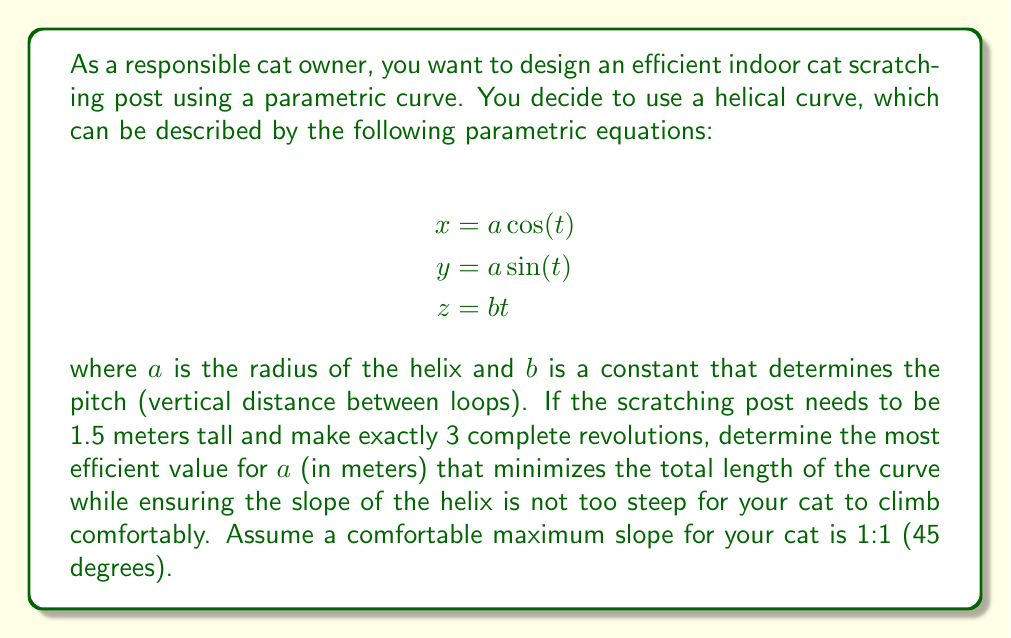Solve this math problem. Let's approach this problem step by step:

1) First, we need to understand the relationship between $a$, $b$, and the height of the post:
   - Height = $1.5$ m
   - Number of revolutions = 3
   - Total angle traversed = $3 \cdot 2\pi = 6\pi$
   
   We can write: $1.5 = b \cdot 6\pi$
   Therefore, $b = \frac{1.5}{6\pi} = \frac{1}{4\pi} \approx 0.0796$ m

2) The slope of the helix is given by $\frac{b}{a}$. For a maximum slope of 1:1, we need:

   $\frac{b}{a} \leq 1$
   $\frac{1}{4\pi a} \leq 1$
   $a \geq \frac{1}{4\pi} \approx 0.0796$ m

3) Now, we need to find the length of the helix. The arc length of a parametric curve is given by:

   $$L = \int_{0}^{6\pi} \sqrt{\left(\frac{dx}{dt}\right)^2 + \left(\frac{dy}{dt}\right)^2 + \left(\frac{dz}{dt}\right)^2} dt$$

4) Calculating the derivatives:
   $\frac{dx}{dt} = -a \sin(t)$
   $\frac{dy}{dt} = a \cos(t)$
   $\frac{dz}{dt} = b = \frac{1}{4\pi}$

5) Substituting into the arc length formula:

   $$L = \int_{0}^{6\pi} \sqrt{(-a \sin(t))^2 + (a \cos(t))^2 + (\frac{1}{4\pi})^2} dt$$
   $$= \int_{0}^{6\pi} \sqrt{a^2 (\sin^2(t) + \cos^2(t)) + (\frac{1}{4\pi})^2} dt$$
   $$= \int_{0}^{6\pi} \sqrt{a^2 + (\frac{1}{4\pi})^2} dt$$
   $$= 6\pi \sqrt{a^2 + (\frac{1}{4\pi})^2}$$

6) To minimize this length, we want $a$ to be as small as possible while still satisfying the slope condition. Therefore, the most efficient value for $a$ is:

   $a = \frac{1}{4\pi} \approx 0.0796$ m

This value of $a$ ensures the slope is exactly 1:1, which is the steepest allowed slope that's still comfortable for the cat to climb.
Answer: The most efficient value for $a$ is $\frac{1}{4\pi} \approx 0.0796$ meters. 